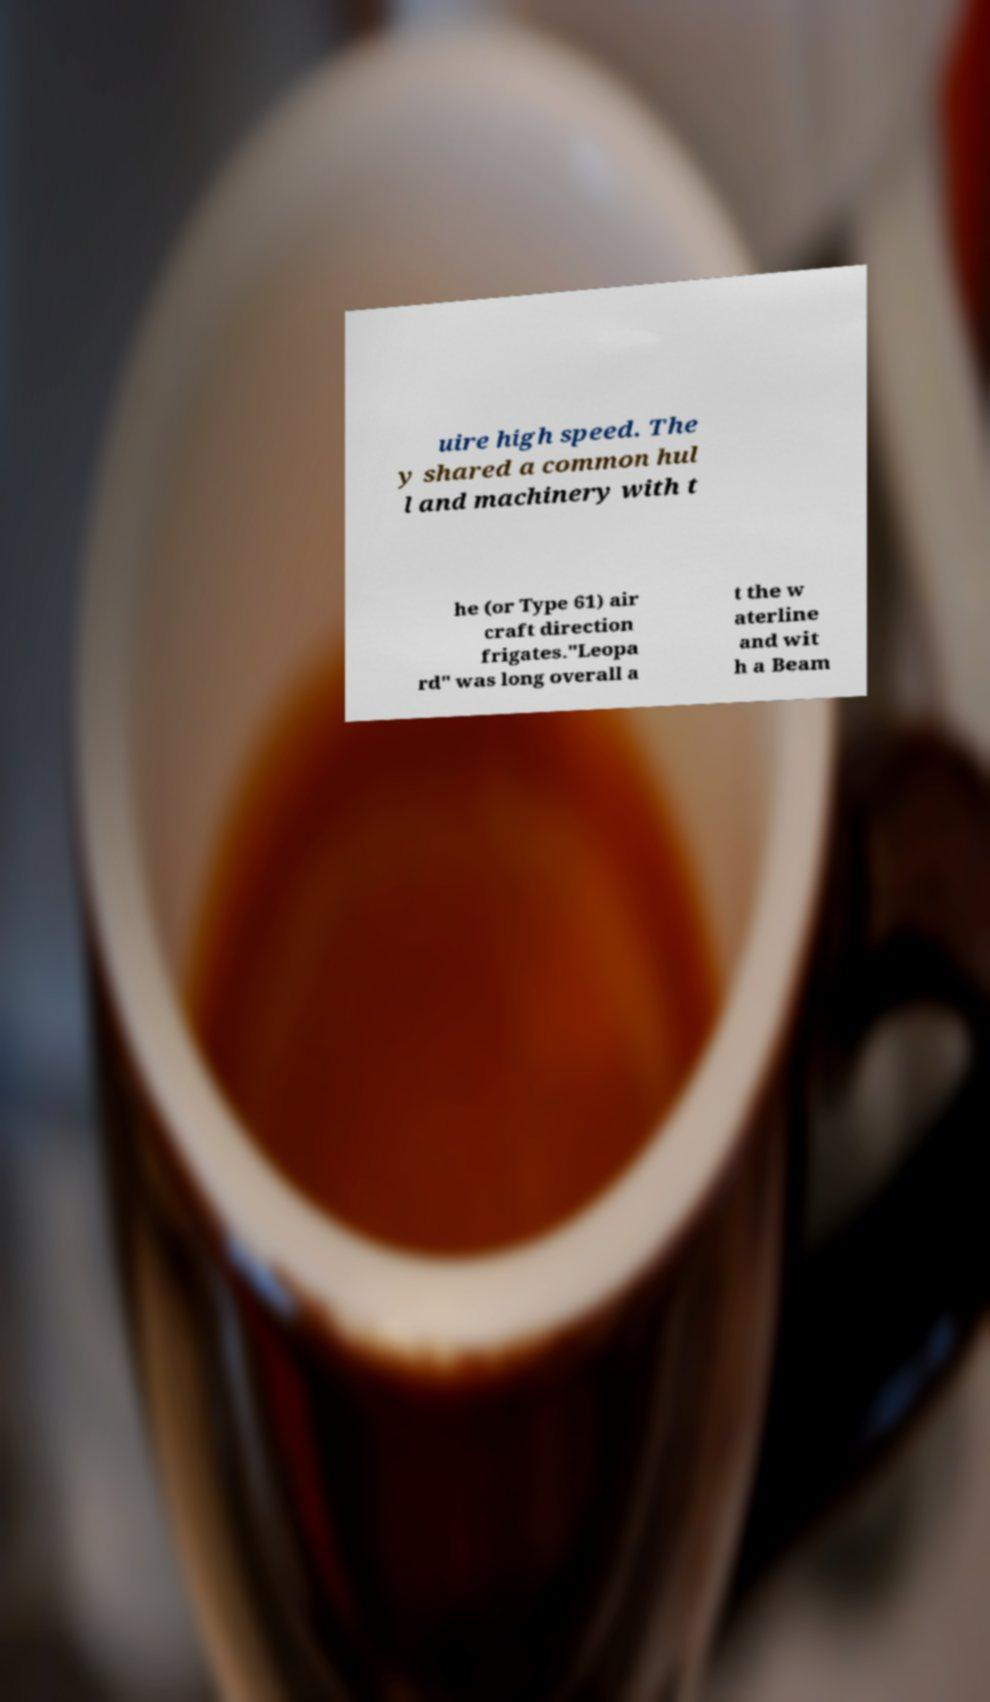For documentation purposes, I need the text within this image transcribed. Could you provide that? uire high speed. The y shared a common hul l and machinery with t he (or Type 61) air craft direction frigates."Leopa rd" was long overall a t the w aterline and wit h a Beam 